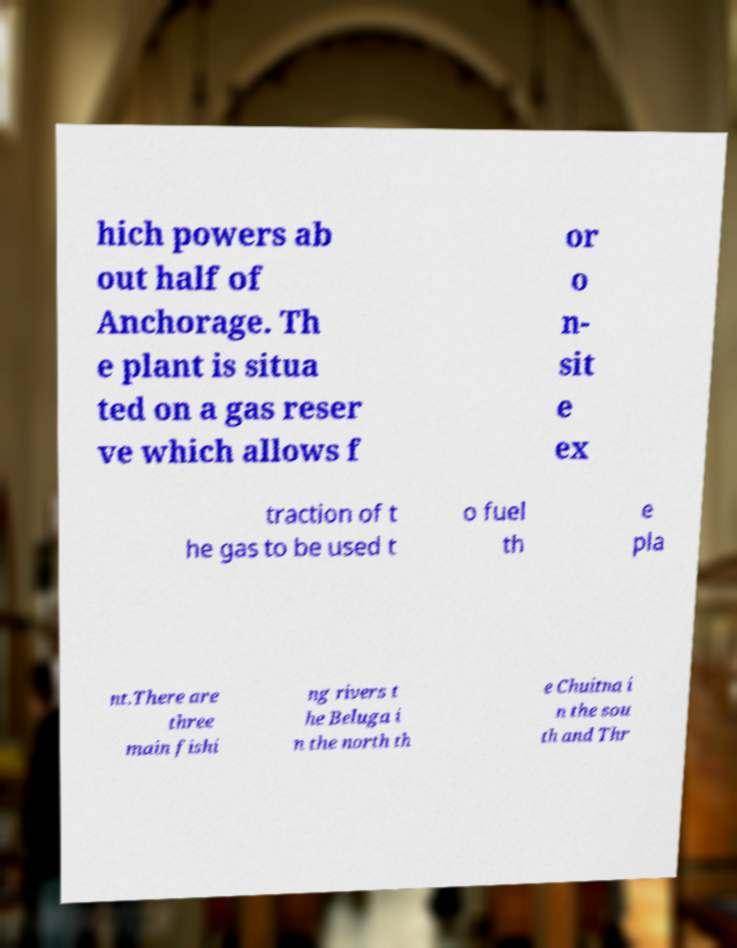I need the written content from this picture converted into text. Can you do that? hich powers ab out half of Anchorage. Th e plant is situa ted on a gas reser ve which allows f or o n- sit e ex traction of t he gas to be used t o fuel th e pla nt.There are three main fishi ng rivers t he Beluga i n the north th e Chuitna i n the sou th and Thr 